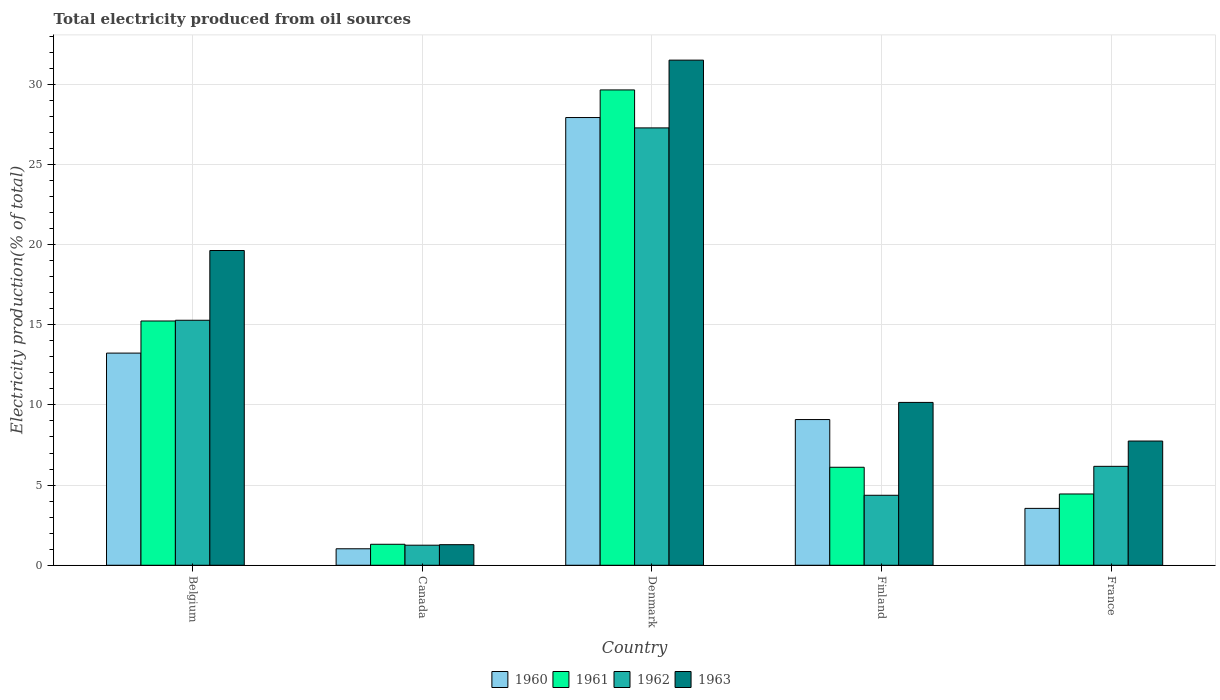How many different coloured bars are there?
Make the answer very short. 4. How many bars are there on the 5th tick from the left?
Give a very brief answer. 4. How many bars are there on the 2nd tick from the right?
Keep it short and to the point. 4. What is the label of the 2nd group of bars from the left?
Offer a terse response. Canada. In how many cases, is the number of bars for a given country not equal to the number of legend labels?
Keep it short and to the point. 0. What is the total electricity produced in 1963 in Denmark?
Your answer should be compact. 31.51. Across all countries, what is the maximum total electricity produced in 1962?
Offer a terse response. 27.28. Across all countries, what is the minimum total electricity produced in 1962?
Your answer should be very brief. 1.25. In which country was the total electricity produced in 1963 maximum?
Keep it short and to the point. Denmark. What is the total total electricity produced in 1960 in the graph?
Your answer should be very brief. 54.82. What is the difference between the total electricity produced in 1960 in Belgium and that in France?
Ensure brevity in your answer.  9.68. What is the difference between the total electricity produced in 1961 in Canada and the total electricity produced in 1960 in France?
Ensure brevity in your answer.  -2.24. What is the average total electricity produced in 1962 per country?
Offer a terse response. 10.87. What is the difference between the total electricity produced of/in 1962 and total electricity produced of/in 1960 in France?
Provide a succinct answer. 2.62. What is the ratio of the total electricity produced in 1963 in Belgium to that in Denmark?
Offer a terse response. 0.62. Is the difference between the total electricity produced in 1962 in Canada and Denmark greater than the difference between the total electricity produced in 1960 in Canada and Denmark?
Your answer should be compact. Yes. What is the difference between the highest and the second highest total electricity produced in 1961?
Make the answer very short. 23.53. What is the difference between the highest and the lowest total electricity produced in 1962?
Make the answer very short. 26.03. In how many countries, is the total electricity produced in 1960 greater than the average total electricity produced in 1960 taken over all countries?
Your response must be concise. 2. What does the 2nd bar from the right in Canada represents?
Give a very brief answer. 1962. Are all the bars in the graph horizontal?
Provide a short and direct response. No. How many countries are there in the graph?
Provide a succinct answer. 5. Are the values on the major ticks of Y-axis written in scientific E-notation?
Provide a succinct answer. No. Does the graph contain any zero values?
Provide a succinct answer. No. Does the graph contain grids?
Offer a terse response. Yes. Where does the legend appear in the graph?
Provide a short and direct response. Bottom center. How many legend labels are there?
Offer a terse response. 4. How are the legend labels stacked?
Your response must be concise. Horizontal. What is the title of the graph?
Ensure brevity in your answer.  Total electricity produced from oil sources. What is the label or title of the Y-axis?
Your answer should be compact. Electricity production(% of total). What is the Electricity production(% of total) of 1960 in Belgium?
Ensure brevity in your answer.  13.23. What is the Electricity production(% of total) in 1961 in Belgium?
Provide a short and direct response. 15.23. What is the Electricity production(% of total) in 1962 in Belgium?
Make the answer very short. 15.28. What is the Electricity production(% of total) of 1963 in Belgium?
Give a very brief answer. 19.63. What is the Electricity production(% of total) of 1960 in Canada?
Keep it short and to the point. 1.03. What is the Electricity production(% of total) of 1961 in Canada?
Offer a very short reply. 1.31. What is the Electricity production(% of total) of 1962 in Canada?
Offer a terse response. 1.25. What is the Electricity production(% of total) in 1963 in Canada?
Make the answer very short. 1.28. What is the Electricity production(% of total) of 1960 in Denmark?
Ensure brevity in your answer.  27.92. What is the Electricity production(% of total) of 1961 in Denmark?
Your answer should be very brief. 29.65. What is the Electricity production(% of total) in 1962 in Denmark?
Make the answer very short. 27.28. What is the Electricity production(% of total) of 1963 in Denmark?
Make the answer very short. 31.51. What is the Electricity production(% of total) of 1960 in Finland?
Give a very brief answer. 9.09. What is the Electricity production(% of total) of 1961 in Finland?
Make the answer very short. 6.11. What is the Electricity production(% of total) of 1962 in Finland?
Offer a very short reply. 4.36. What is the Electricity production(% of total) in 1963 in Finland?
Your answer should be very brief. 10.16. What is the Electricity production(% of total) of 1960 in France?
Make the answer very short. 3.55. What is the Electricity production(% of total) in 1961 in France?
Provide a short and direct response. 4.45. What is the Electricity production(% of total) in 1962 in France?
Your answer should be very brief. 6.17. What is the Electricity production(% of total) of 1963 in France?
Keep it short and to the point. 7.75. Across all countries, what is the maximum Electricity production(% of total) of 1960?
Your answer should be very brief. 27.92. Across all countries, what is the maximum Electricity production(% of total) in 1961?
Your answer should be very brief. 29.65. Across all countries, what is the maximum Electricity production(% of total) in 1962?
Offer a very short reply. 27.28. Across all countries, what is the maximum Electricity production(% of total) in 1963?
Make the answer very short. 31.51. Across all countries, what is the minimum Electricity production(% of total) in 1960?
Offer a terse response. 1.03. Across all countries, what is the minimum Electricity production(% of total) in 1961?
Provide a short and direct response. 1.31. Across all countries, what is the minimum Electricity production(% of total) in 1962?
Your answer should be compact. 1.25. Across all countries, what is the minimum Electricity production(% of total) in 1963?
Provide a succinct answer. 1.28. What is the total Electricity production(% of total) of 1960 in the graph?
Provide a succinct answer. 54.82. What is the total Electricity production(% of total) of 1961 in the graph?
Give a very brief answer. 56.75. What is the total Electricity production(% of total) in 1962 in the graph?
Provide a succinct answer. 54.34. What is the total Electricity production(% of total) in 1963 in the graph?
Give a very brief answer. 70.32. What is the difference between the Electricity production(% of total) of 1960 in Belgium and that in Canada?
Offer a very short reply. 12.2. What is the difference between the Electricity production(% of total) of 1961 in Belgium and that in Canada?
Provide a short and direct response. 13.93. What is the difference between the Electricity production(% of total) in 1962 in Belgium and that in Canada?
Your answer should be compact. 14.03. What is the difference between the Electricity production(% of total) of 1963 in Belgium and that in Canada?
Provide a short and direct response. 18.35. What is the difference between the Electricity production(% of total) of 1960 in Belgium and that in Denmark?
Provide a succinct answer. -14.69. What is the difference between the Electricity production(% of total) of 1961 in Belgium and that in Denmark?
Provide a short and direct response. -14.41. What is the difference between the Electricity production(% of total) in 1962 in Belgium and that in Denmark?
Provide a short and direct response. -12. What is the difference between the Electricity production(% of total) of 1963 in Belgium and that in Denmark?
Give a very brief answer. -11.87. What is the difference between the Electricity production(% of total) of 1960 in Belgium and that in Finland?
Offer a terse response. 4.14. What is the difference between the Electricity production(% of total) of 1961 in Belgium and that in Finland?
Offer a very short reply. 9.12. What is the difference between the Electricity production(% of total) of 1962 in Belgium and that in Finland?
Ensure brevity in your answer.  10.92. What is the difference between the Electricity production(% of total) in 1963 in Belgium and that in Finland?
Your answer should be very brief. 9.47. What is the difference between the Electricity production(% of total) in 1960 in Belgium and that in France?
Provide a succinct answer. 9.68. What is the difference between the Electricity production(% of total) of 1961 in Belgium and that in France?
Your answer should be compact. 10.79. What is the difference between the Electricity production(% of total) of 1962 in Belgium and that in France?
Give a very brief answer. 9.11. What is the difference between the Electricity production(% of total) in 1963 in Belgium and that in France?
Provide a short and direct response. 11.88. What is the difference between the Electricity production(% of total) of 1960 in Canada and that in Denmark?
Offer a very short reply. -26.9. What is the difference between the Electricity production(% of total) in 1961 in Canada and that in Denmark?
Your answer should be compact. -28.34. What is the difference between the Electricity production(% of total) of 1962 in Canada and that in Denmark?
Offer a terse response. -26.03. What is the difference between the Electricity production(% of total) of 1963 in Canada and that in Denmark?
Make the answer very short. -30.22. What is the difference between the Electricity production(% of total) of 1960 in Canada and that in Finland?
Give a very brief answer. -8.06. What is the difference between the Electricity production(% of total) in 1961 in Canada and that in Finland?
Offer a terse response. -4.8. What is the difference between the Electricity production(% of total) of 1962 in Canada and that in Finland?
Provide a succinct answer. -3.11. What is the difference between the Electricity production(% of total) in 1963 in Canada and that in Finland?
Ensure brevity in your answer.  -8.87. What is the difference between the Electricity production(% of total) of 1960 in Canada and that in France?
Provide a short and direct response. -2.52. What is the difference between the Electricity production(% of total) in 1961 in Canada and that in France?
Keep it short and to the point. -3.14. What is the difference between the Electricity production(% of total) of 1962 in Canada and that in France?
Provide a succinct answer. -4.92. What is the difference between the Electricity production(% of total) of 1963 in Canada and that in France?
Offer a very short reply. -6.46. What is the difference between the Electricity production(% of total) of 1960 in Denmark and that in Finland?
Offer a very short reply. 18.84. What is the difference between the Electricity production(% of total) in 1961 in Denmark and that in Finland?
Provide a succinct answer. 23.53. What is the difference between the Electricity production(% of total) of 1962 in Denmark and that in Finland?
Provide a succinct answer. 22.91. What is the difference between the Electricity production(% of total) in 1963 in Denmark and that in Finland?
Offer a terse response. 21.35. What is the difference between the Electricity production(% of total) in 1960 in Denmark and that in France?
Keep it short and to the point. 24.38. What is the difference between the Electricity production(% of total) of 1961 in Denmark and that in France?
Ensure brevity in your answer.  25.2. What is the difference between the Electricity production(% of total) of 1962 in Denmark and that in France?
Keep it short and to the point. 21.11. What is the difference between the Electricity production(% of total) of 1963 in Denmark and that in France?
Offer a terse response. 23.76. What is the difference between the Electricity production(% of total) of 1960 in Finland and that in France?
Offer a very short reply. 5.54. What is the difference between the Electricity production(% of total) of 1961 in Finland and that in France?
Offer a terse response. 1.67. What is the difference between the Electricity production(% of total) in 1962 in Finland and that in France?
Provide a short and direct response. -1.8. What is the difference between the Electricity production(% of total) of 1963 in Finland and that in France?
Give a very brief answer. 2.41. What is the difference between the Electricity production(% of total) of 1960 in Belgium and the Electricity production(% of total) of 1961 in Canada?
Your response must be concise. 11.92. What is the difference between the Electricity production(% of total) of 1960 in Belgium and the Electricity production(% of total) of 1962 in Canada?
Keep it short and to the point. 11.98. What is the difference between the Electricity production(% of total) of 1960 in Belgium and the Electricity production(% of total) of 1963 in Canada?
Ensure brevity in your answer.  11.95. What is the difference between the Electricity production(% of total) of 1961 in Belgium and the Electricity production(% of total) of 1962 in Canada?
Give a very brief answer. 13.98. What is the difference between the Electricity production(% of total) in 1961 in Belgium and the Electricity production(% of total) in 1963 in Canada?
Ensure brevity in your answer.  13.95. What is the difference between the Electricity production(% of total) of 1962 in Belgium and the Electricity production(% of total) of 1963 in Canada?
Keep it short and to the point. 14. What is the difference between the Electricity production(% of total) of 1960 in Belgium and the Electricity production(% of total) of 1961 in Denmark?
Give a very brief answer. -16.41. What is the difference between the Electricity production(% of total) of 1960 in Belgium and the Electricity production(% of total) of 1962 in Denmark?
Provide a succinct answer. -14.05. What is the difference between the Electricity production(% of total) in 1960 in Belgium and the Electricity production(% of total) in 1963 in Denmark?
Keep it short and to the point. -18.27. What is the difference between the Electricity production(% of total) of 1961 in Belgium and the Electricity production(% of total) of 1962 in Denmark?
Ensure brevity in your answer.  -12.04. What is the difference between the Electricity production(% of total) in 1961 in Belgium and the Electricity production(% of total) in 1963 in Denmark?
Offer a very short reply. -16.27. What is the difference between the Electricity production(% of total) in 1962 in Belgium and the Electricity production(% of total) in 1963 in Denmark?
Offer a terse response. -16.22. What is the difference between the Electricity production(% of total) in 1960 in Belgium and the Electricity production(% of total) in 1961 in Finland?
Ensure brevity in your answer.  7.12. What is the difference between the Electricity production(% of total) in 1960 in Belgium and the Electricity production(% of total) in 1962 in Finland?
Ensure brevity in your answer.  8.87. What is the difference between the Electricity production(% of total) of 1960 in Belgium and the Electricity production(% of total) of 1963 in Finland?
Your response must be concise. 3.08. What is the difference between the Electricity production(% of total) in 1961 in Belgium and the Electricity production(% of total) in 1962 in Finland?
Offer a very short reply. 10.87. What is the difference between the Electricity production(% of total) of 1961 in Belgium and the Electricity production(% of total) of 1963 in Finland?
Your answer should be very brief. 5.08. What is the difference between the Electricity production(% of total) of 1962 in Belgium and the Electricity production(% of total) of 1963 in Finland?
Offer a very short reply. 5.12. What is the difference between the Electricity production(% of total) of 1960 in Belgium and the Electricity production(% of total) of 1961 in France?
Your answer should be very brief. 8.79. What is the difference between the Electricity production(% of total) in 1960 in Belgium and the Electricity production(% of total) in 1962 in France?
Your answer should be compact. 7.06. What is the difference between the Electricity production(% of total) of 1960 in Belgium and the Electricity production(% of total) of 1963 in France?
Ensure brevity in your answer.  5.48. What is the difference between the Electricity production(% of total) in 1961 in Belgium and the Electricity production(% of total) in 1962 in France?
Keep it short and to the point. 9.07. What is the difference between the Electricity production(% of total) of 1961 in Belgium and the Electricity production(% of total) of 1963 in France?
Give a very brief answer. 7.49. What is the difference between the Electricity production(% of total) of 1962 in Belgium and the Electricity production(% of total) of 1963 in France?
Keep it short and to the point. 7.53. What is the difference between the Electricity production(% of total) in 1960 in Canada and the Electricity production(% of total) in 1961 in Denmark?
Provide a succinct answer. -28.62. What is the difference between the Electricity production(% of total) in 1960 in Canada and the Electricity production(% of total) in 1962 in Denmark?
Your answer should be compact. -26.25. What is the difference between the Electricity production(% of total) of 1960 in Canada and the Electricity production(% of total) of 1963 in Denmark?
Give a very brief answer. -30.48. What is the difference between the Electricity production(% of total) in 1961 in Canada and the Electricity production(% of total) in 1962 in Denmark?
Make the answer very short. -25.97. What is the difference between the Electricity production(% of total) of 1961 in Canada and the Electricity production(% of total) of 1963 in Denmark?
Give a very brief answer. -30.2. What is the difference between the Electricity production(% of total) of 1962 in Canada and the Electricity production(% of total) of 1963 in Denmark?
Provide a succinct answer. -30.25. What is the difference between the Electricity production(% of total) in 1960 in Canada and the Electricity production(% of total) in 1961 in Finland?
Provide a short and direct response. -5.08. What is the difference between the Electricity production(% of total) in 1960 in Canada and the Electricity production(% of total) in 1962 in Finland?
Keep it short and to the point. -3.34. What is the difference between the Electricity production(% of total) of 1960 in Canada and the Electricity production(% of total) of 1963 in Finland?
Offer a terse response. -9.13. What is the difference between the Electricity production(% of total) in 1961 in Canada and the Electricity production(% of total) in 1962 in Finland?
Keep it short and to the point. -3.06. What is the difference between the Electricity production(% of total) of 1961 in Canada and the Electricity production(% of total) of 1963 in Finland?
Offer a terse response. -8.85. What is the difference between the Electricity production(% of total) in 1962 in Canada and the Electricity production(% of total) in 1963 in Finland?
Your answer should be very brief. -8.91. What is the difference between the Electricity production(% of total) in 1960 in Canada and the Electricity production(% of total) in 1961 in France?
Your answer should be compact. -3.42. What is the difference between the Electricity production(% of total) of 1960 in Canada and the Electricity production(% of total) of 1962 in France?
Your answer should be very brief. -5.14. What is the difference between the Electricity production(% of total) of 1960 in Canada and the Electricity production(% of total) of 1963 in France?
Provide a short and direct response. -6.72. What is the difference between the Electricity production(% of total) of 1961 in Canada and the Electricity production(% of total) of 1962 in France?
Your response must be concise. -4.86. What is the difference between the Electricity production(% of total) of 1961 in Canada and the Electricity production(% of total) of 1963 in France?
Offer a very short reply. -6.44. What is the difference between the Electricity production(% of total) in 1962 in Canada and the Electricity production(% of total) in 1963 in France?
Your answer should be compact. -6.5. What is the difference between the Electricity production(% of total) in 1960 in Denmark and the Electricity production(% of total) in 1961 in Finland?
Your response must be concise. 21.81. What is the difference between the Electricity production(% of total) in 1960 in Denmark and the Electricity production(% of total) in 1962 in Finland?
Offer a terse response. 23.56. What is the difference between the Electricity production(% of total) in 1960 in Denmark and the Electricity production(% of total) in 1963 in Finland?
Offer a very short reply. 17.77. What is the difference between the Electricity production(% of total) of 1961 in Denmark and the Electricity production(% of total) of 1962 in Finland?
Make the answer very short. 25.28. What is the difference between the Electricity production(% of total) of 1961 in Denmark and the Electricity production(% of total) of 1963 in Finland?
Your answer should be compact. 19.49. What is the difference between the Electricity production(% of total) of 1962 in Denmark and the Electricity production(% of total) of 1963 in Finland?
Keep it short and to the point. 17.12. What is the difference between the Electricity production(% of total) in 1960 in Denmark and the Electricity production(% of total) in 1961 in France?
Your response must be concise. 23.48. What is the difference between the Electricity production(% of total) in 1960 in Denmark and the Electricity production(% of total) in 1962 in France?
Keep it short and to the point. 21.75. What is the difference between the Electricity production(% of total) in 1960 in Denmark and the Electricity production(% of total) in 1963 in France?
Give a very brief answer. 20.18. What is the difference between the Electricity production(% of total) of 1961 in Denmark and the Electricity production(% of total) of 1962 in France?
Your answer should be very brief. 23.48. What is the difference between the Electricity production(% of total) in 1961 in Denmark and the Electricity production(% of total) in 1963 in France?
Your answer should be compact. 21.9. What is the difference between the Electricity production(% of total) of 1962 in Denmark and the Electricity production(% of total) of 1963 in France?
Your response must be concise. 19.53. What is the difference between the Electricity production(% of total) in 1960 in Finland and the Electricity production(% of total) in 1961 in France?
Your answer should be very brief. 4.64. What is the difference between the Electricity production(% of total) in 1960 in Finland and the Electricity production(% of total) in 1962 in France?
Provide a succinct answer. 2.92. What is the difference between the Electricity production(% of total) of 1960 in Finland and the Electricity production(% of total) of 1963 in France?
Your answer should be compact. 1.34. What is the difference between the Electricity production(% of total) of 1961 in Finland and the Electricity production(% of total) of 1962 in France?
Provide a succinct answer. -0.06. What is the difference between the Electricity production(% of total) of 1961 in Finland and the Electricity production(% of total) of 1963 in France?
Your answer should be compact. -1.64. What is the difference between the Electricity production(% of total) of 1962 in Finland and the Electricity production(% of total) of 1963 in France?
Give a very brief answer. -3.38. What is the average Electricity production(% of total) of 1960 per country?
Ensure brevity in your answer.  10.96. What is the average Electricity production(% of total) of 1961 per country?
Offer a terse response. 11.35. What is the average Electricity production(% of total) of 1962 per country?
Make the answer very short. 10.87. What is the average Electricity production(% of total) in 1963 per country?
Give a very brief answer. 14.06. What is the difference between the Electricity production(% of total) of 1960 and Electricity production(% of total) of 1961 in Belgium?
Your answer should be very brief. -2. What is the difference between the Electricity production(% of total) in 1960 and Electricity production(% of total) in 1962 in Belgium?
Ensure brevity in your answer.  -2.05. What is the difference between the Electricity production(% of total) in 1960 and Electricity production(% of total) in 1963 in Belgium?
Your answer should be compact. -6.4. What is the difference between the Electricity production(% of total) of 1961 and Electricity production(% of total) of 1962 in Belgium?
Provide a succinct answer. -0.05. What is the difference between the Electricity production(% of total) of 1961 and Electricity production(% of total) of 1963 in Belgium?
Provide a short and direct response. -4.4. What is the difference between the Electricity production(% of total) of 1962 and Electricity production(% of total) of 1963 in Belgium?
Offer a very short reply. -4.35. What is the difference between the Electricity production(% of total) of 1960 and Electricity production(% of total) of 1961 in Canada?
Your response must be concise. -0.28. What is the difference between the Electricity production(% of total) of 1960 and Electricity production(% of total) of 1962 in Canada?
Your answer should be very brief. -0.22. What is the difference between the Electricity production(% of total) of 1960 and Electricity production(% of total) of 1963 in Canada?
Your answer should be compact. -0.26. What is the difference between the Electricity production(% of total) in 1961 and Electricity production(% of total) in 1962 in Canada?
Provide a succinct answer. 0.06. What is the difference between the Electricity production(% of total) of 1961 and Electricity production(% of total) of 1963 in Canada?
Provide a succinct answer. 0.03. What is the difference between the Electricity production(% of total) in 1962 and Electricity production(% of total) in 1963 in Canada?
Offer a very short reply. -0.03. What is the difference between the Electricity production(% of total) of 1960 and Electricity production(% of total) of 1961 in Denmark?
Provide a short and direct response. -1.72. What is the difference between the Electricity production(% of total) in 1960 and Electricity production(% of total) in 1962 in Denmark?
Provide a short and direct response. 0.65. What is the difference between the Electricity production(% of total) in 1960 and Electricity production(% of total) in 1963 in Denmark?
Keep it short and to the point. -3.58. What is the difference between the Electricity production(% of total) of 1961 and Electricity production(% of total) of 1962 in Denmark?
Ensure brevity in your answer.  2.37. What is the difference between the Electricity production(% of total) of 1961 and Electricity production(% of total) of 1963 in Denmark?
Provide a succinct answer. -1.86. What is the difference between the Electricity production(% of total) in 1962 and Electricity production(% of total) in 1963 in Denmark?
Keep it short and to the point. -4.23. What is the difference between the Electricity production(% of total) of 1960 and Electricity production(% of total) of 1961 in Finland?
Your answer should be very brief. 2.98. What is the difference between the Electricity production(% of total) in 1960 and Electricity production(% of total) in 1962 in Finland?
Your response must be concise. 4.72. What is the difference between the Electricity production(% of total) in 1960 and Electricity production(% of total) in 1963 in Finland?
Your answer should be very brief. -1.07. What is the difference between the Electricity production(% of total) in 1961 and Electricity production(% of total) in 1962 in Finland?
Offer a terse response. 1.75. What is the difference between the Electricity production(% of total) in 1961 and Electricity production(% of total) in 1963 in Finland?
Ensure brevity in your answer.  -4.04. What is the difference between the Electricity production(% of total) in 1962 and Electricity production(% of total) in 1963 in Finland?
Offer a terse response. -5.79. What is the difference between the Electricity production(% of total) in 1960 and Electricity production(% of total) in 1961 in France?
Your answer should be very brief. -0.9. What is the difference between the Electricity production(% of total) of 1960 and Electricity production(% of total) of 1962 in France?
Provide a succinct answer. -2.62. What is the difference between the Electricity production(% of total) in 1960 and Electricity production(% of total) in 1963 in France?
Your answer should be compact. -4.2. What is the difference between the Electricity production(% of total) in 1961 and Electricity production(% of total) in 1962 in France?
Your response must be concise. -1.72. What is the difference between the Electricity production(% of total) in 1961 and Electricity production(% of total) in 1963 in France?
Provide a short and direct response. -3.3. What is the difference between the Electricity production(% of total) of 1962 and Electricity production(% of total) of 1963 in France?
Your response must be concise. -1.58. What is the ratio of the Electricity production(% of total) of 1960 in Belgium to that in Canada?
Provide a short and direct response. 12.86. What is the ratio of the Electricity production(% of total) of 1961 in Belgium to that in Canada?
Make the answer very short. 11.64. What is the ratio of the Electricity production(% of total) in 1962 in Belgium to that in Canada?
Your answer should be compact. 12.21. What is the ratio of the Electricity production(% of total) of 1963 in Belgium to that in Canada?
Your answer should be compact. 15.29. What is the ratio of the Electricity production(% of total) in 1960 in Belgium to that in Denmark?
Offer a very short reply. 0.47. What is the ratio of the Electricity production(% of total) in 1961 in Belgium to that in Denmark?
Your answer should be compact. 0.51. What is the ratio of the Electricity production(% of total) in 1962 in Belgium to that in Denmark?
Your answer should be very brief. 0.56. What is the ratio of the Electricity production(% of total) in 1963 in Belgium to that in Denmark?
Ensure brevity in your answer.  0.62. What is the ratio of the Electricity production(% of total) in 1960 in Belgium to that in Finland?
Offer a very short reply. 1.46. What is the ratio of the Electricity production(% of total) in 1961 in Belgium to that in Finland?
Provide a succinct answer. 2.49. What is the ratio of the Electricity production(% of total) of 1962 in Belgium to that in Finland?
Make the answer very short. 3.5. What is the ratio of the Electricity production(% of total) in 1963 in Belgium to that in Finland?
Provide a short and direct response. 1.93. What is the ratio of the Electricity production(% of total) in 1960 in Belgium to that in France?
Ensure brevity in your answer.  3.73. What is the ratio of the Electricity production(% of total) in 1961 in Belgium to that in France?
Your answer should be very brief. 3.43. What is the ratio of the Electricity production(% of total) of 1962 in Belgium to that in France?
Your answer should be very brief. 2.48. What is the ratio of the Electricity production(% of total) of 1963 in Belgium to that in France?
Your answer should be very brief. 2.53. What is the ratio of the Electricity production(% of total) of 1960 in Canada to that in Denmark?
Keep it short and to the point. 0.04. What is the ratio of the Electricity production(% of total) in 1961 in Canada to that in Denmark?
Your answer should be compact. 0.04. What is the ratio of the Electricity production(% of total) in 1962 in Canada to that in Denmark?
Provide a succinct answer. 0.05. What is the ratio of the Electricity production(% of total) in 1963 in Canada to that in Denmark?
Provide a short and direct response. 0.04. What is the ratio of the Electricity production(% of total) in 1960 in Canada to that in Finland?
Offer a terse response. 0.11. What is the ratio of the Electricity production(% of total) in 1961 in Canada to that in Finland?
Provide a succinct answer. 0.21. What is the ratio of the Electricity production(% of total) of 1962 in Canada to that in Finland?
Give a very brief answer. 0.29. What is the ratio of the Electricity production(% of total) in 1963 in Canada to that in Finland?
Offer a very short reply. 0.13. What is the ratio of the Electricity production(% of total) in 1960 in Canada to that in France?
Your answer should be very brief. 0.29. What is the ratio of the Electricity production(% of total) in 1961 in Canada to that in France?
Keep it short and to the point. 0.29. What is the ratio of the Electricity production(% of total) of 1962 in Canada to that in France?
Keep it short and to the point. 0.2. What is the ratio of the Electricity production(% of total) of 1963 in Canada to that in France?
Provide a short and direct response. 0.17. What is the ratio of the Electricity production(% of total) of 1960 in Denmark to that in Finland?
Provide a short and direct response. 3.07. What is the ratio of the Electricity production(% of total) in 1961 in Denmark to that in Finland?
Provide a short and direct response. 4.85. What is the ratio of the Electricity production(% of total) in 1962 in Denmark to that in Finland?
Your answer should be compact. 6.25. What is the ratio of the Electricity production(% of total) of 1963 in Denmark to that in Finland?
Make the answer very short. 3.1. What is the ratio of the Electricity production(% of total) in 1960 in Denmark to that in France?
Offer a very short reply. 7.87. What is the ratio of the Electricity production(% of total) of 1961 in Denmark to that in France?
Your answer should be very brief. 6.67. What is the ratio of the Electricity production(% of total) in 1962 in Denmark to that in France?
Your answer should be compact. 4.42. What is the ratio of the Electricity production(% of total) in 1963 in Denmark to that in France?
Offer a very short reply. 4.07. What is the ratio of the Electricity production(% of total) in 1960 in Finland to that in France?
Make the answer very short. 2.56. What is the ratio of the Electricity production(% of total) of 1961 in Finland to that in France?
Make the answer very short. 1.37. What is the ratio of the Electricity production(% of total) in 1962 in Finland to that in France?
Keep it short and to the point. 0.71. What is the ratio of the Electricity production(% of total) of 1963 in Finland to that in France?
Provide a short and direct response. 1.31. What is the difference between the highest and the second highest Electricity production(% of total) of 1960?
Ensure brevity in your answer.  14.69. What is the difference between the highest and the second highest Electricity production(% of total) in 1961?
Offer a terse response. 14.41. What is the difference between the highest and the second highest Electricity production(% of total) in 1962?
Give a very brief answer. 12. What is the difference between the highest and the second highest Electricity production(% of total) in 1963?
Provide a succinct answer. 11.87. What is the difference between the highest and the lowest Electricity production(% of total) in 1960?
Offer a terse response. 26.9. What is the difference between the highest and the lowest Electricity production(% of total) in 1961?
Keep it short and to the point. 28.34. What is the difference between the highest and the lowest Electricity production(% of total) of 1962?
Offer a very short reply. 26.03. What is the difference between the highest and the lowest Electricity production(% of total) in 1963?
Your answer should be very brief. 30.22. 